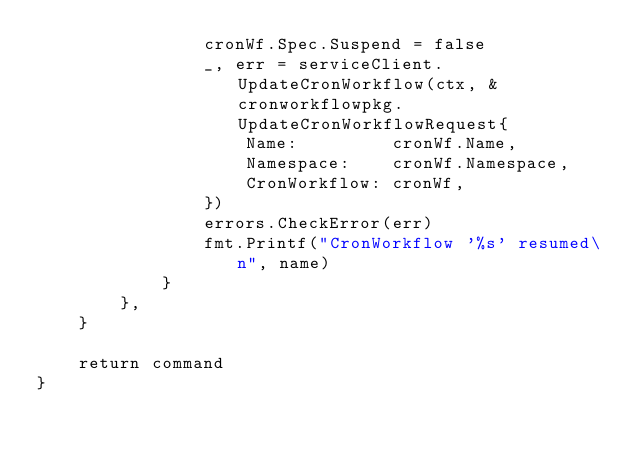<code> <loc_0><loc_0><loc_500><loc_500><_Go_>				cronWf.Spec.Suspend = false
				_, err = serviceClient.UpdateCronWorkflow(ctx, &cronworkflowpkg.UpdateCronWorkflowRequest{
					Name:         cronWf.Name,
					Namespace:    cronWf.Namespace,
					CronWorkflow: cronWf,
				})
				errors.CheckError(err)
				fmt.Printf("CronWorkflow '%s' resumed\n", name)
			}
		},
	}

	return command
}
</code> 